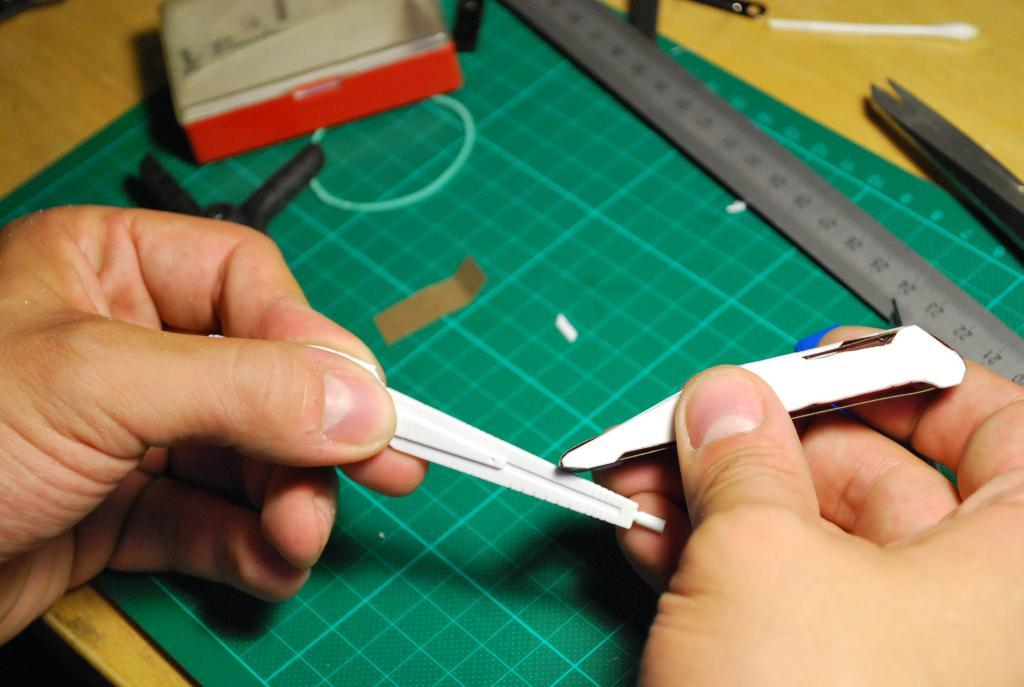What is the person in the image holding? The person is holding two objects in the image. What can be seen on the cutting mat in the image? There are items on the cutting mat, including a rubber band, a ruler, a small piece of paper, and a box. What is the purpose of the rubber band on the cutting mat? The rubber band on the cutting mat is likely used to hold or organize items. What is the ruler used for on the cutting mat? The ruler is likely used for measuring or drawing straight lines on the items on the cutting mat. What is the small piece of paper on the cutting mat used for? The small piece of paper on the cutting mat might be used for labeling or marking items. What is the box on the cutting mat used for? The box on the cutting mat might be used for storing or organizing items. Where is the cutting mat located in the image? The cutting mat is on a table in the image. How does the person in the image adjust the car's mirrors while holding the two objects? There is no car or mirrors present in the image; the person is holding two objects and working on a cutting mat on a table. Can you tell me where the sink is located in the image? There is no sink present in the image; the image shows a person working on a cutting mat on a table with various items. 